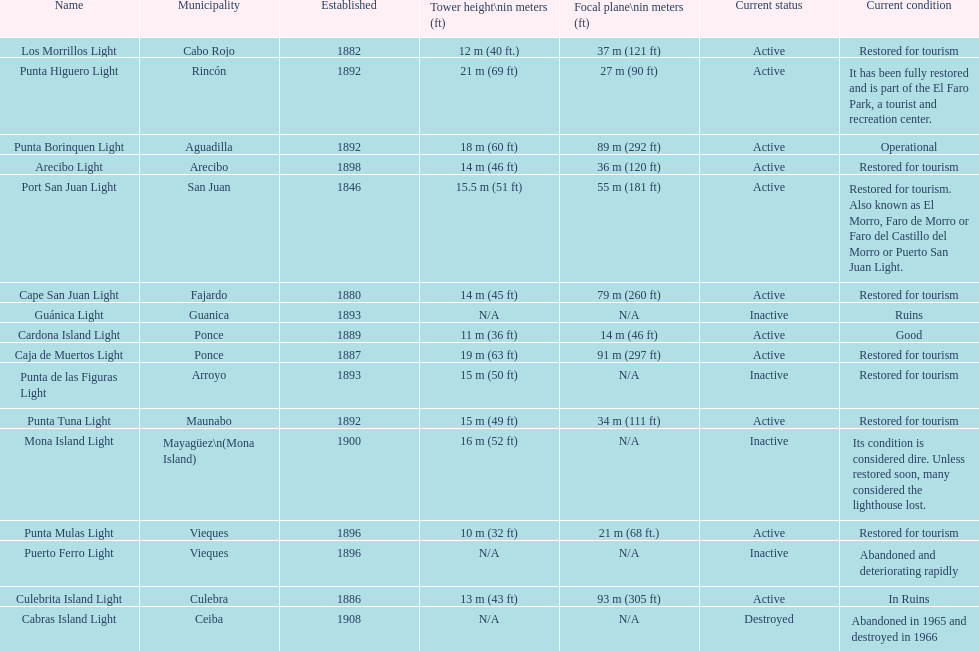The difference in years from 1882 to 1889 7. 